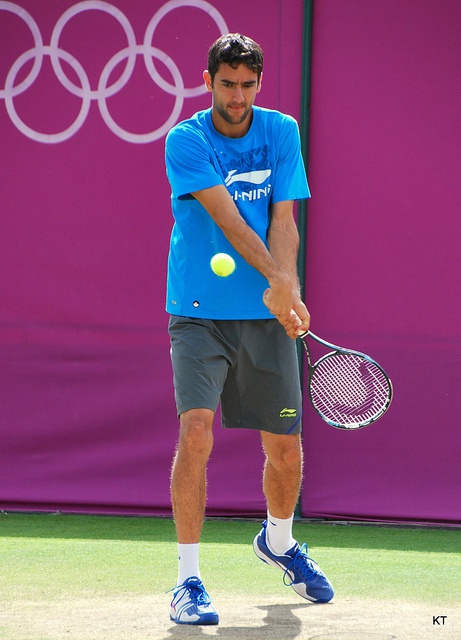Describe the objects in this image and their specific colors. I can see people in purple, blue, salmon, black, and gray tones, tennis racket in purple, white, darkgray, and violet tones, and sports ball in purple, yellow, khaki, beige, and teal tones in this image. 